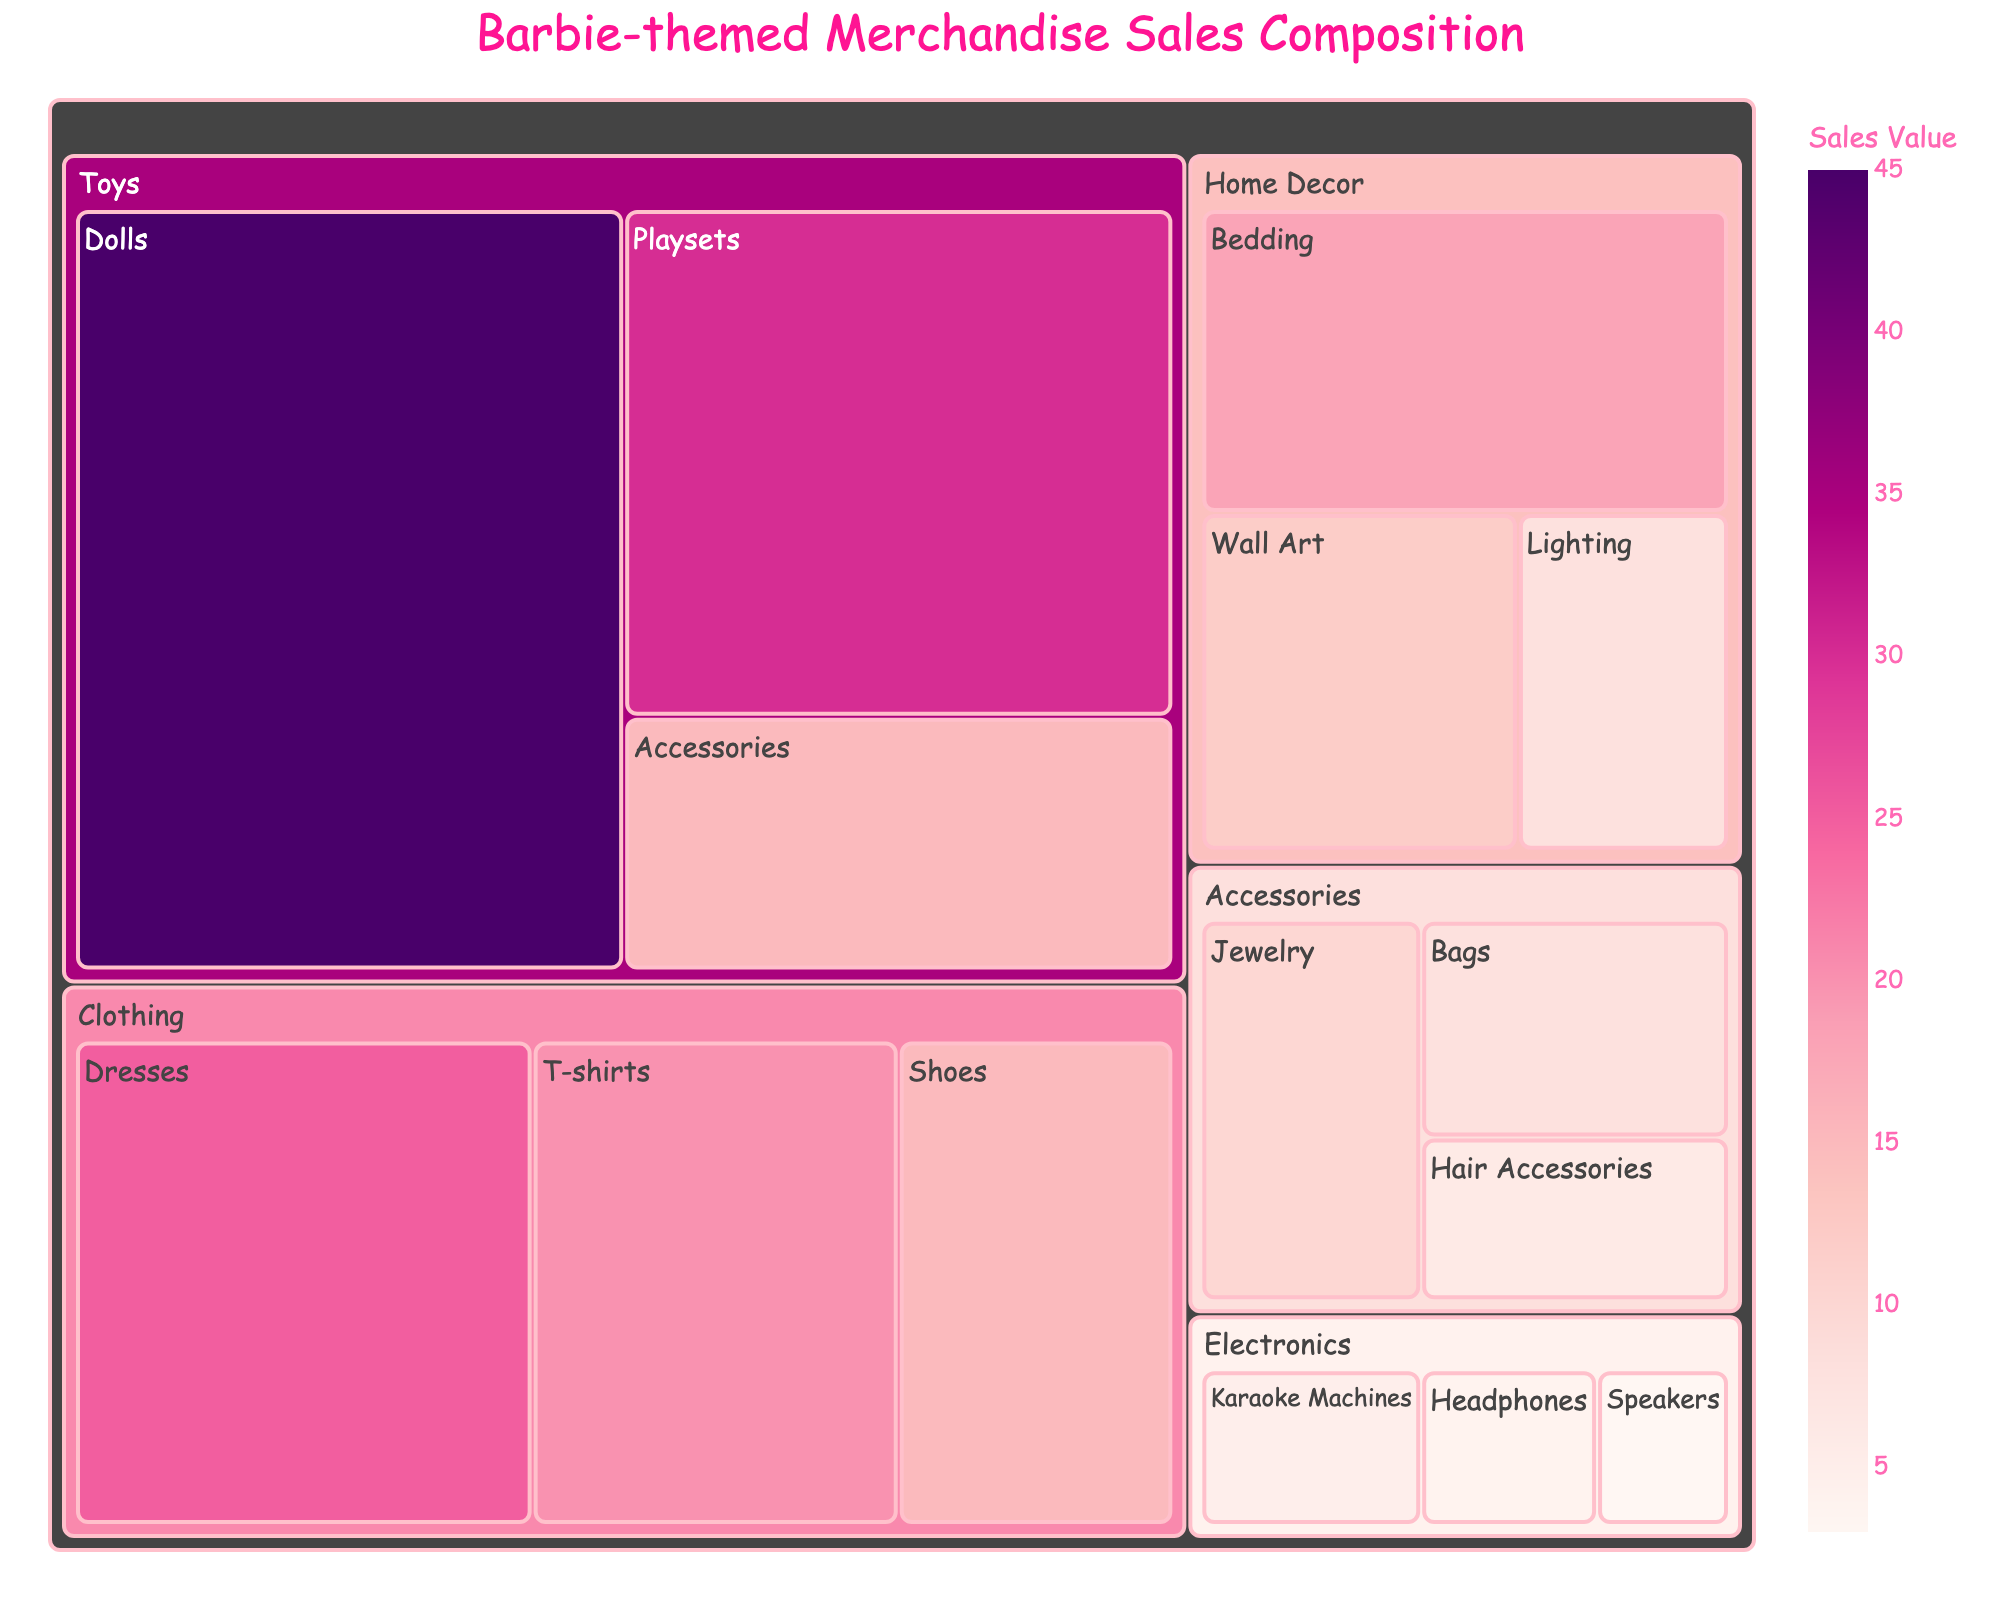What's the title of the treemap? The title is displayed prominently at the top of the treemap.
Answer: Barbie-themed Merchandise Sales Composition Which subcategory has the highest sales value? By looking at the size of the boxes, the largest box under the “Toys” category is “Dolls”.
Answer: Dolls How many categories are represented in the treemap? The boxes have labels for each category, visually separating them.
Answer: 5 What is the combined sales value of the subcategories under Clothing? Sum the values for “Dresses”, “T-shirts”, and “Shoes”: 25 + 20 + 15 = 60.
Answer: 60 Compare the sales value of Playsets with Dresses. Which is higher and by how much? The value for Playsets is 30 and for Dresses is 25. So, 30 - 25 = 5.
Answer: Playsets, by 5 What is the sales value for the Home Decor category? Sum the values of “Bedding”, “Wall Art”, and “Lighting”: 18 + 12 + 8 = 38.
Answer: 38 Which subcategory in Accessories has the smallest sales value? Within Accessories, the smallest box is for “Hair Accessories”.
Answer: Hair Accessories How does the total sales value of Accessories compare to Electronics? Sum values for Accessories: 10 + 8 + 6 = 24. Sum values for Electronics: 5 + 4 + 3 = 12. Compare the sums, 24 is greater than 12.
Answer: Accessories is greater What is the most popular subcategory within the Electronics category? The largest box in Electronics is “Karaoke Machines”.
Answer: Karaoke Machines 